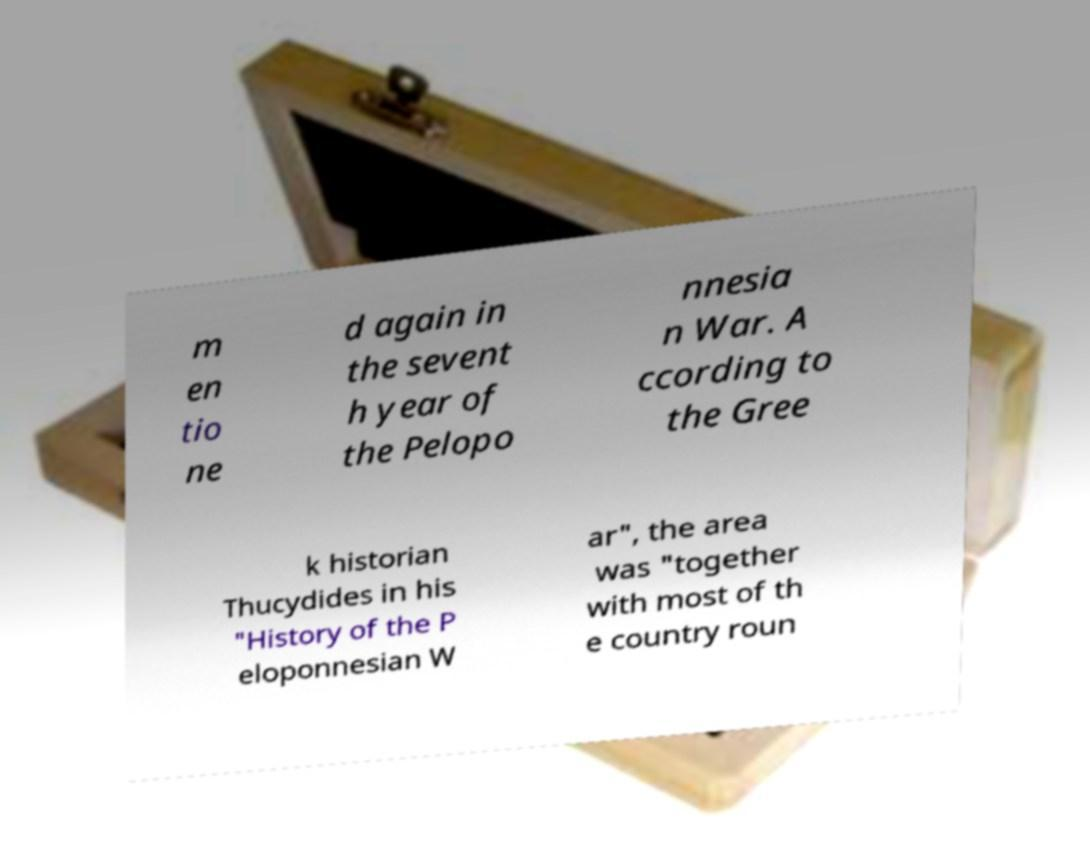For documentation purposes, I need the text within this image transcribed. Could you provide that? m en tio ne d again in the sevent h year of the Pelopo nnesia n War. A ccording to the Gree k historian Thucydides in his "History of the P eloponnesian W ar", the area was "together with most of th e country roun 